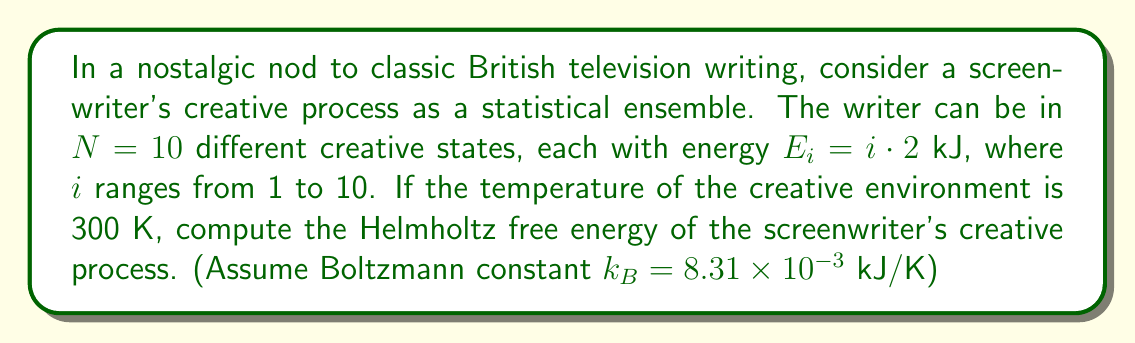Can you solve this math problem? To solve this problem, we'll use the principles of statistical mechanics:

1) The Helmholtz free energy is given by:
   $$F = -k_B T \ln Z$$
   where $Z$ is the partition function, $k_B$ is the Boltzmann constant, and $T$ is the temperature.

2) The partition function for a discrete system is:
   $$Z = \sum_{i=1}^N e^{-\beta E_i}$$
   where $\beta = \frac{1}{k_B T}$

3) Calculate $\beta$:
   $$\beta = \frac{1}{k_B T} = \frac{1}{(8.31 \times 10^{-3} \text{ kJ/K})(300 \text{ K})} = 0.4 \text{ kJ}^{-1}$$

4) Calculate the partition function:
   $$Z = \sum_{i=1}^{10} e^{-0.4 \cdot (i \cdot 2)} = e^{-0.8} + e^{-1.6} + e^{-2.4} + ... + e^{-8}$$

5) Using a calculator or computer, we find:
   $$Z \approx 1.8019$$

6) Now we can calculate the free energy:
   $$F = -k_B T \ln Z$$
   $$F = -(8.31 \times 10^{-3} \text{ kJ/K})(300 \text{ K}) \ln(1.8019)$$
   $$F \approx -1.4896 \text{ kJ}$$
Answer: $-1.49 \text{ kJ}$ 